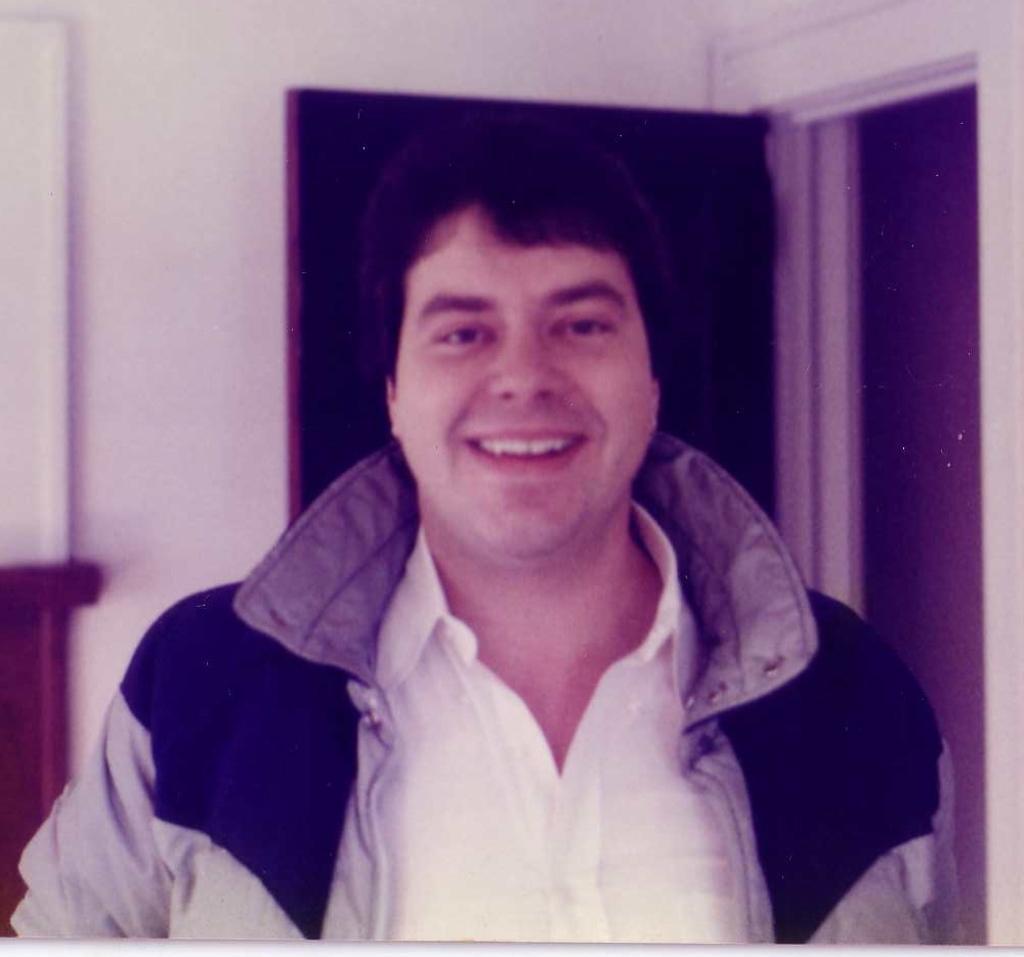In one or two sentences, can you explain what this image depicts? In the middle of the image a man is standing and smiling. Behind him there is a wall and door. 